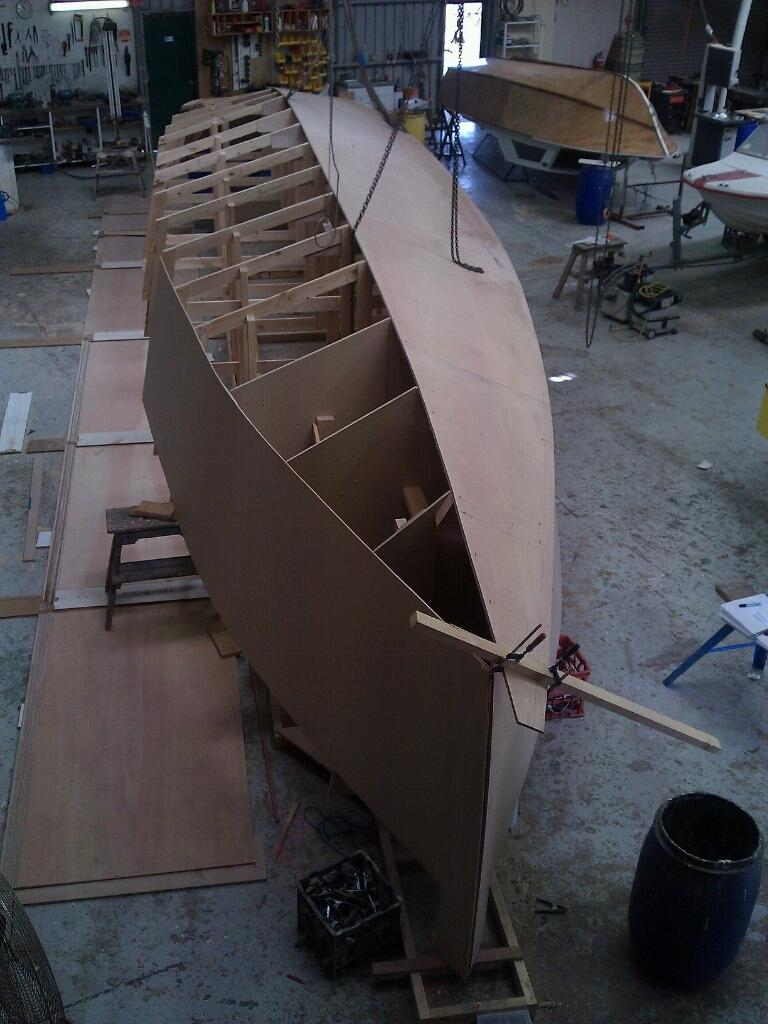What type of building model is on the floor in the image? There is a building model of a boat on the floor. What type of containers are in the image? There are bins in the image. What type of material is present in the image? There are chains in the image. What type of furniture is in the image? There is a table in the image. What type of architectural feature is in the image? There are walls in the image. What type of zipper can be seen on the grandfather's birthday present in the image? There is no grandfather, birthday present, or zipper present in the image. 